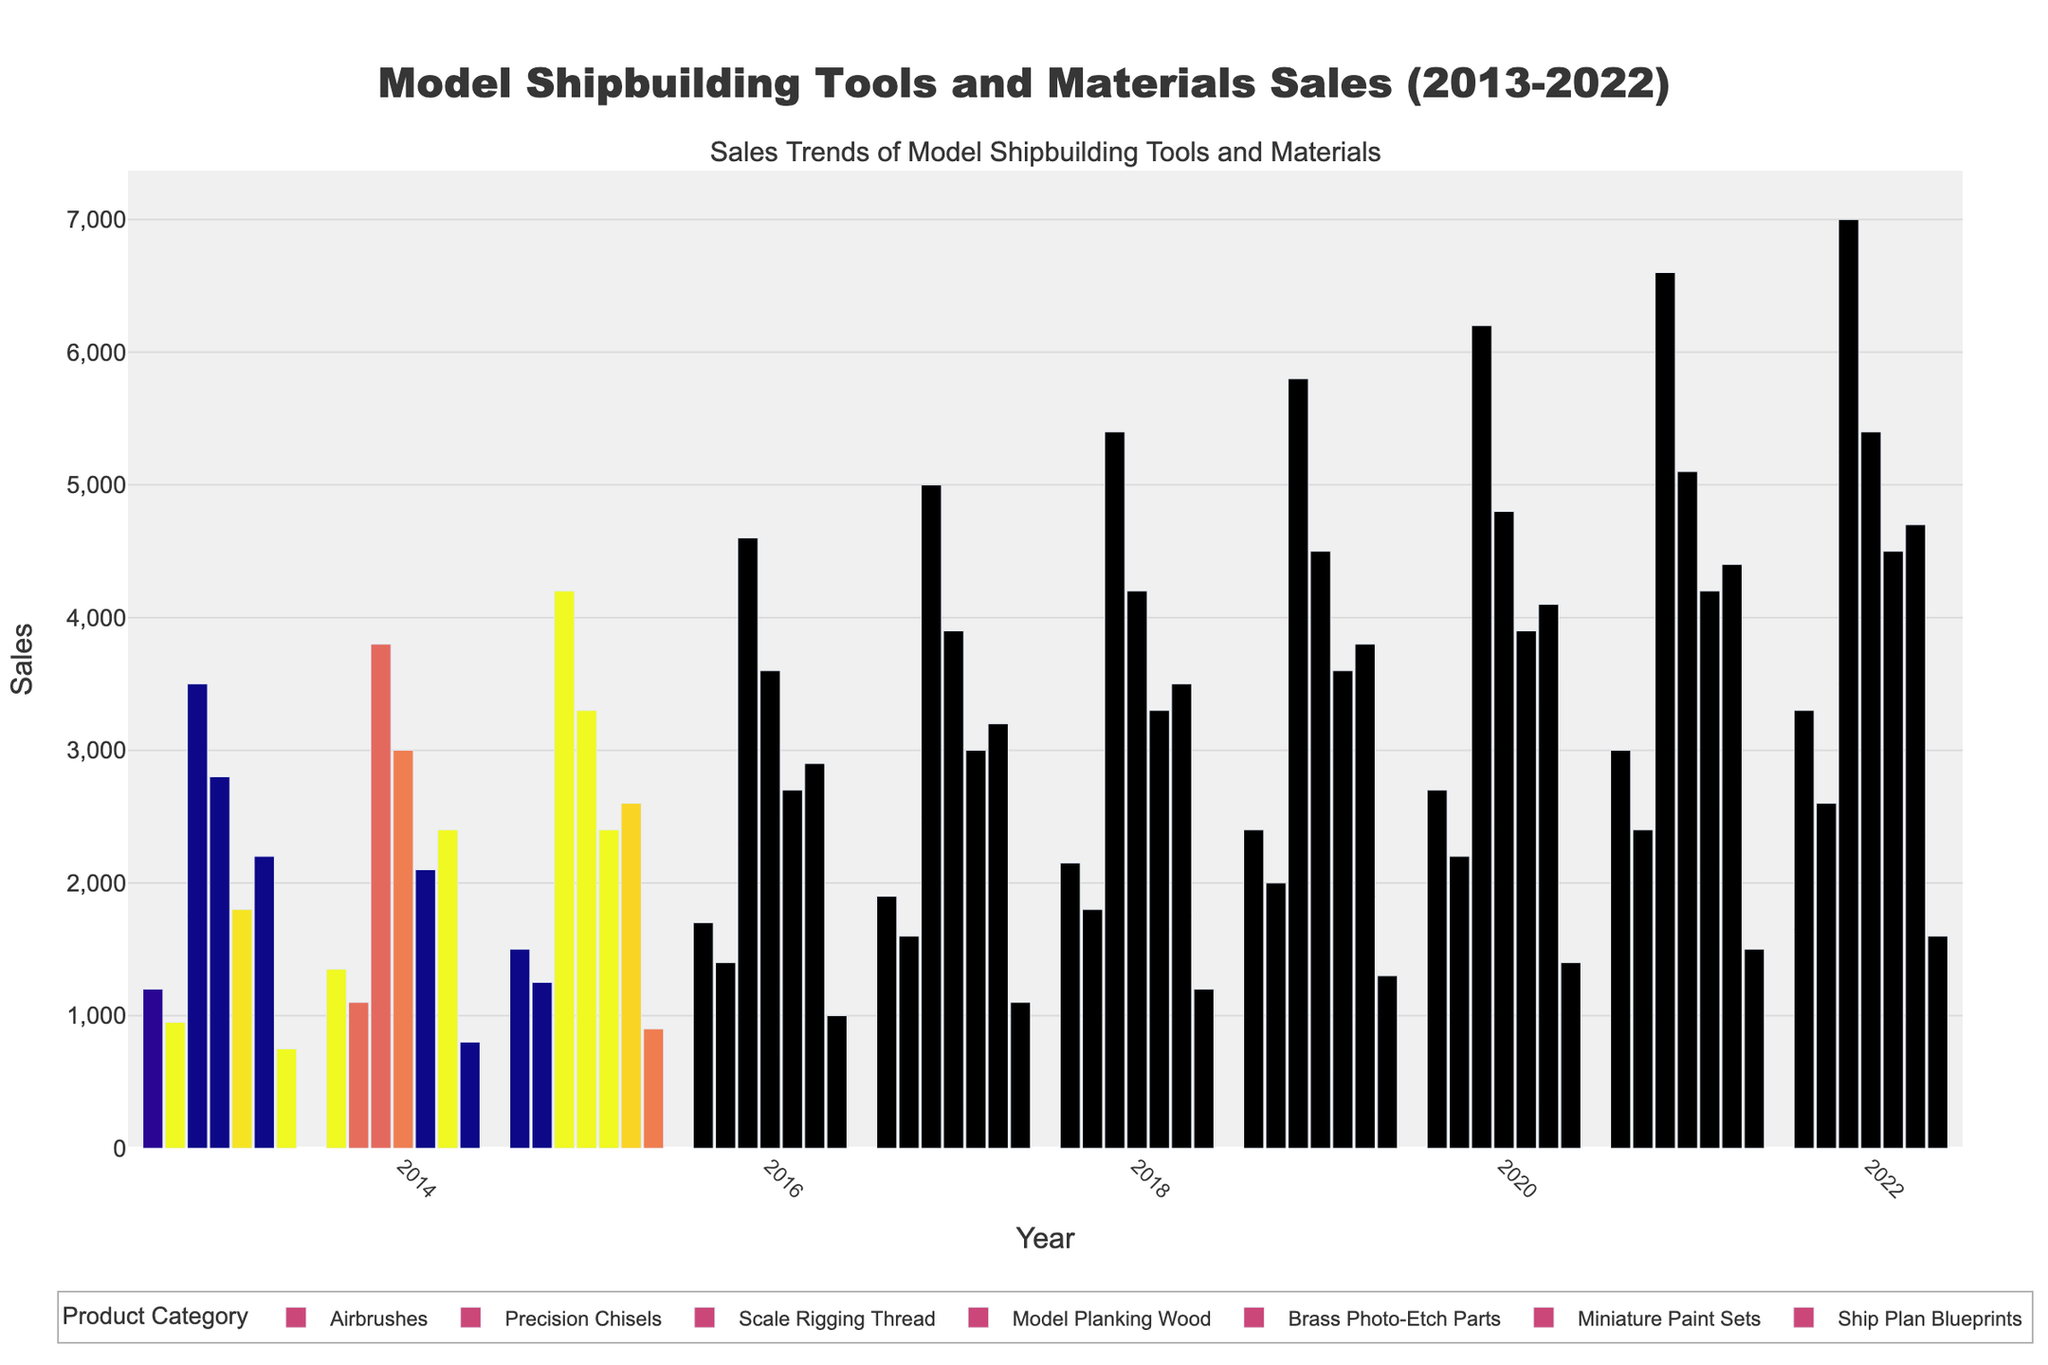Which product category saw the highest sales in 2018? Look at the bars for 2018; the tallest bar represents Scale Rigging Thread.
Answer: Scale Rigging Thread How much did sales for Airbrushes increase from 2013 to 2022? Subtract the sales in 2013 from the sales in 2022 for Airbrushes: 3300 - 1200 = 2100.
Answer: 2100 Which year had the highest total sales across all product categories? Sum the sales for each year and compare: 
- 2013: 12400 
- 2014: 13550 
- 2015: 14950 
- 2016: 16400 
- 2017: 17900 
- 2018: 19450 
- 2019: 21000 
- 2020: 22600 
- 2021: 24300 
- 2022: 26000. The highest is in 2022 with 26000.
Answer: 2022 What is the cumulative sales difference between Miniature Paint Sets and Ship Plan Blueprints in 2020? Subtract 2020 sales of Ship Plan Blueprints from Miniature Paint Sets: 4100 - 1400 = 2700.
Answer: 2700 Which product had both the lowest sales in 2013 and the highest sales in 2018? Look at the shortest bar in 2013 and the tallest bars in 2018. The product is Scale Rigging Thread.
Answer: Scale Rigging Thread How has the sales trend for Brass Photo-Etch Parts evolved between 2016 and 2020? Compare sales from 2016 to 2020: 
- 2016: 2700 
- 2017: 3000 
- 2018: 3300 
- 2019: 3600 
- 2020: 3900. There is a consistent increase each year.
Answer: Consistent increase Which product's sales growth rate was the highest from 2017 to 2022? Calculate the growth rate for each product from 2017 to 2022: 
- Airbrushes: (3300 - 1900) / 1900 * 100 ≈ 74% 
- Precision Chisels: (2600 - 1600) / 1600 * 100 ≈ 63% 
- Scale Rigging Thread: (7000 - 5000) / 5000 * 100 ≈ 40% 
- Model Planking Wood: (5400 - 3900) / 3900 * 100 ≈ 38% 
- Brass Photo-Etch Parts: (4500 - 3000) / 3000 * 100 ≈ 50% 
- Miniature Paint Sets: (4700 - 3200) / 3200 * 100 ≈ 47% 
- Ship Plan Blueprints: (1600 - 1100) / 1100 * 100 ≈ 45%. Airbrushes had the highest growth rate.
Answer: Airbrushes Compared to 2019, what was the percentage increase in Scale Rigging Thread sales in 2020? Calculate the percentage increase: (6200 - 5800) / 5800 * 100 ≈ 6.90%
Answer: 6.90% Which product shows the least variation in sales over the decade? Identify the product with the smallest range between the lowest and highest sales figures. Calculate the range for each product:
- Airbrushes: 3300 - 1200 = 2100
- Precision Chisels: 2600 - 950 = 1650
- Scale Rigging Thread: 7000 - 3500 = 3500
- Model Planking Wood: 5400 - 2800 = 2600
- Brass Photo-Etch Parts: 4500 - 1800 = 2700
- Miniature Paint Sets: 4700 - 2200 = 2500
- Ship Plan Blueprints: 1600 - 750 = 850. Ship Plan Blueprints has the least variation.
Answer: Ship Plan Blueprints 